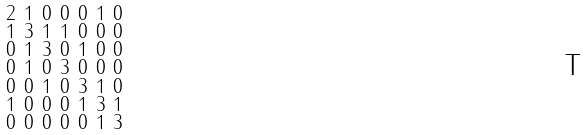Convert formula to latex. <formula><loc_0><loc_0><loc_500><loc_500>\begin{smallmatrix} 2 & 1 & 0 & 0 & 0 & 1 & 0 \\ 1 & 3 & 1 & 1 & 0 & 0 & 0 \\ 0 & 1 & 3 & 0 & 1 & 0 & 0 \\ 0 & 1 & 0 & 3 & 0 & 0 & 0 \\ 0 & 0 & 1 & 0 & 3 & 1 & 0 \\ 1 & 0 & 0 & 0 & 1 & 3 & 1 \\ 0 & 0 & 0 & 0 & 0 & 1 & 3 \end{smallmatrix}</formula> 